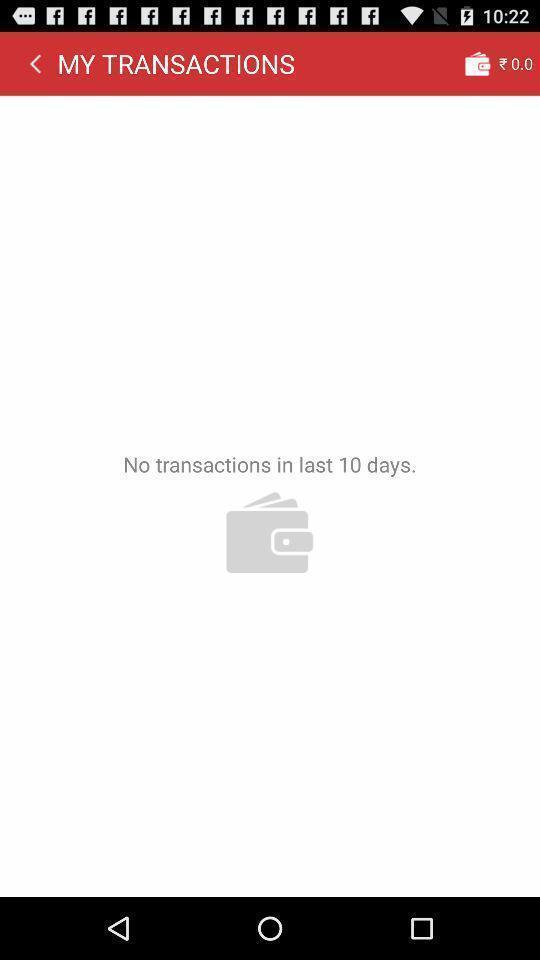Describe the visual elements of this screenshot. Screen showing no transactions. 